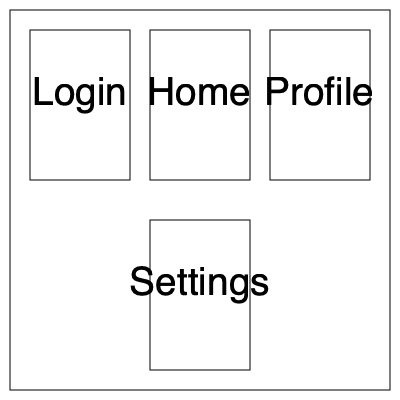Basándote en el diagrama de flujo de usuario proporcionado, ¿cuál es la secuencia correcta de pantallas que un usuario seguiría para cerrar sesión en la aplicación, asumiendo que comienza en la pantalla de Inicio (Home)? Para determinar la secuencia correcta de pantallas para cerrar sesión, sigamos estos pasos:

1. El usuario comienza en la pantalla de Inicio (Home).
2. Desde la pantalla de Inicio, observamos una flecha que conduce a la pantalla de Configuración (Settings).
3. En la pantalla de Configuración, vemos una flecha que regresa a la pantalla de Inicio, pero también notamos una flecha que sale de la parte izquierda.
4. Esta flecha izquierda se conecta con otra flecha que lleva de vuelta a la pantalla de Inicio.
5. Sin embargo, si seguimos esta flecha hacia arriba, vemos que se conecta con la pantalla de Inicio de sesión (Login).
6. Dado que estamos buscando cerrar sesión, esta última conexión con la pantalla de Inicio de sesión representa la acción de cerrar sesión.

Por lo tanto, la secuencia correcta de pantallas para cerrar sesión es:

Inicio (Home) -> Configuración (Settings) -> Inicio de sesión (Login)

Esta secuencia representa el flujo típico donde un usuario va a la configuración para encontrar la opción de cerrar sesión, y luego es redirigido a la pantalla de inicio de sesión una vez que la sesión se ha cerrado.
Answer: Home -> Settings -> Login 